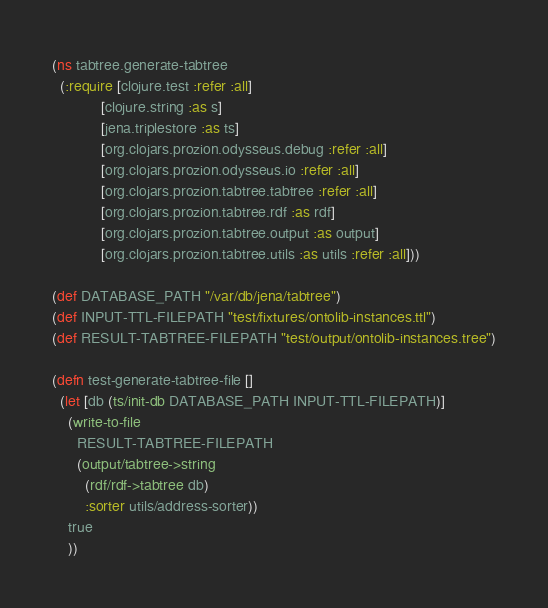Convert code to text. <code><loc_0><loc_0><loc_500><loc_500><_Clojure_>(ns tabtree.generate-tabtree
  (:require [clojure.test :refer :all]
            [clojure.string :as s]
            [jena.triplestore :as ts]
            [org.clojars.prozion.odysseus.debug :refer :all]
            [org.clojars.prozion.odysseus.io :refer :all]
            [org.clojars.prozion.tabtree.tabtree :refer :all]
            [org.clojars.prozion.tabtree.rdf :as rdf]
            [org.clojars.prozion.tabtree.output :as output]
            [org.clojars.prozion.tabtree.utils :as utils :refer :all]))

(def DATABASE_PATH "/var/db/jena/tabtree")
(def INPUT-TTL-FILEPATH "test/fixtures/ontolib-instances.ttl")
(def RESULT-TABTREE-FILEPATH "test/output/ontolib-instances.tree")

(defn test-generate-tabtree-file []
  (let [db (ts/init-db DATABASE_PATH INPUT-TTL-FILEPATH)]
    (write-to-file
      RESULT-TABTREE-FILEPATH
      (output/tabtree->string
        (rdf/rdf->tabtree db)
        :sorter utils/address-sorter))
    true
    ))
</code> 